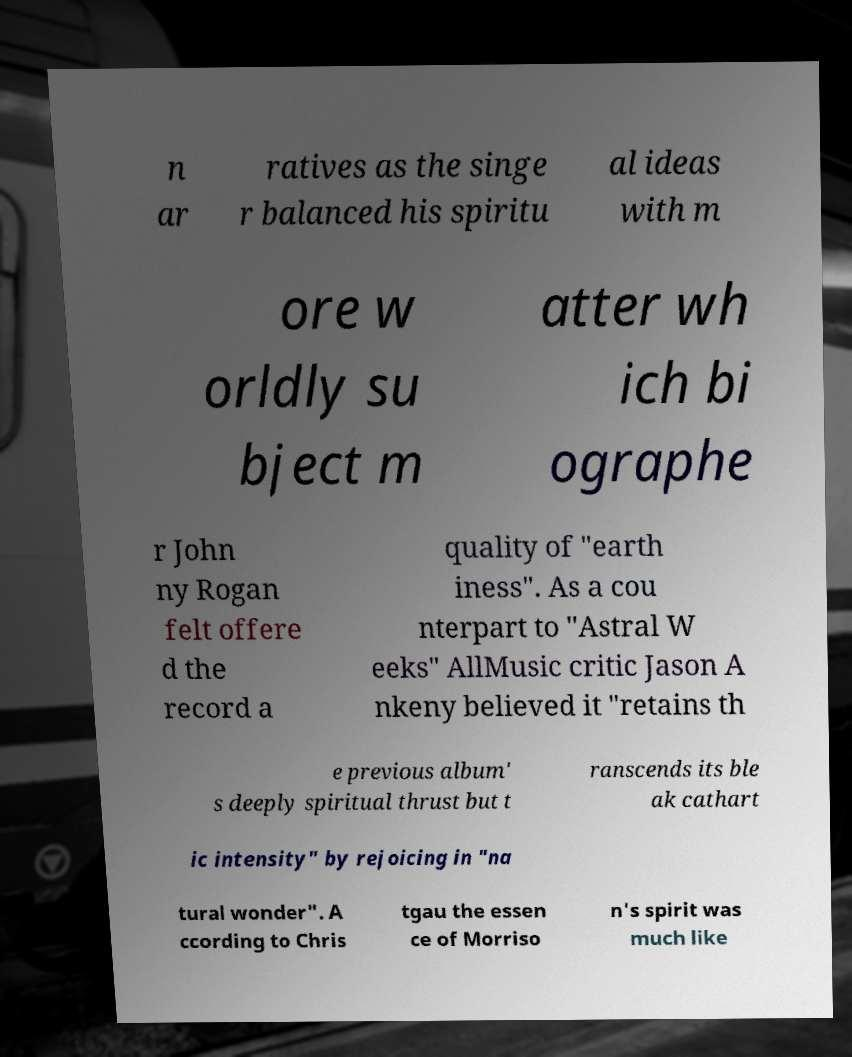Please read and relay the text visible in this image. What does it say? n ar ratives as the singe r balanced his spiritu al ideas with m ore w orldly su bject m atter wh ich bi ographe r John ny Rogan felt offere d the record a quality of "earth iness". As a cou nterpart to "Astral W eeks" AllMusic critic Jason A nkeny believed it "retains th e previous album' s deeply spiritual thrust but t ranscends its ble ak cathart ic intensity" by rejoicing in "na tural wonder". A ccording to Chris tgau the essen ce of Morriso n's spirit was much like 